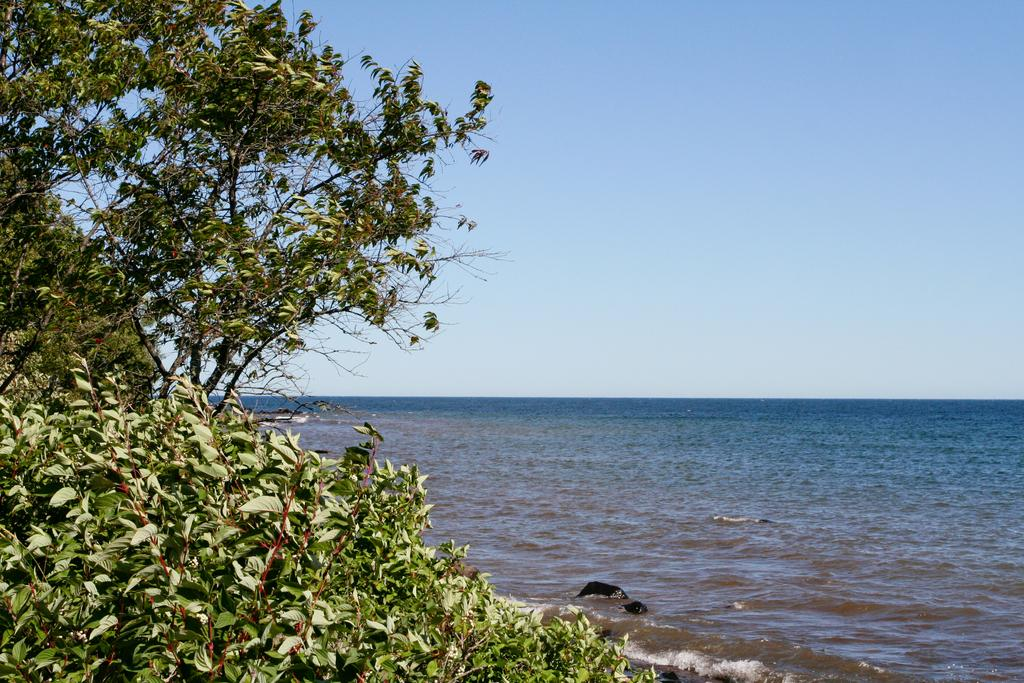What type of vegetation is on the left side of the image? There are trees with branches and leaves on the left side of the image. What can be seen on the right side of the image? There is water on the right side of the image. What is visible at the top of the image? The sky is visible at the top of the image. Where can you find the marble chess set in the image? There is no marble chess set present in the image. What type of snack is being served in the image? The image does not show any snacks, such as popcorn. 